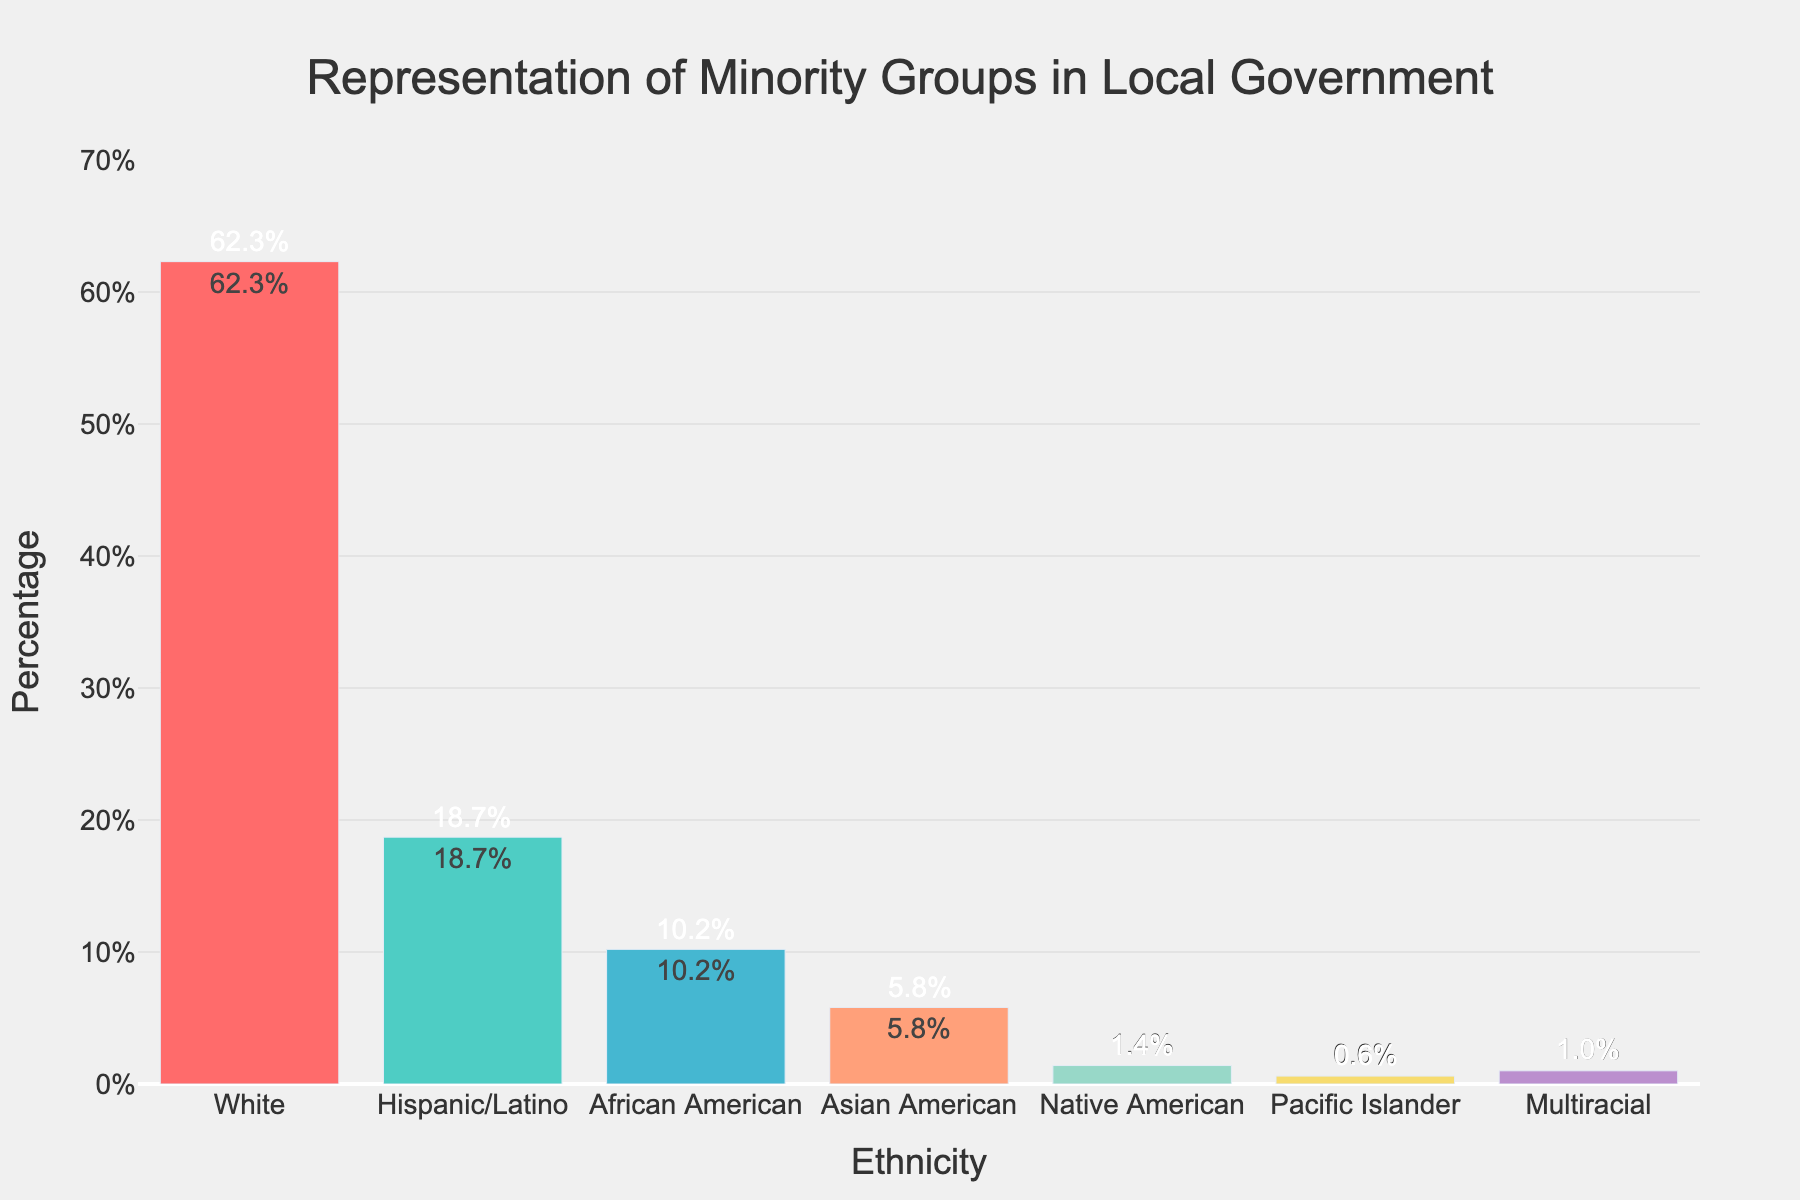What ethnicity has the highest percentage representation in local government according to the chart? By examining the heights of the bars, the bar for 'White' is the tallest, corresponding to the number 62.3. Therefore, 'White' has the highest percentage representation.
Answer: White Which ethnicities have a percentage representation of less than 2% in local government? By looking at the heights of the bars and their corresponding percentages, the 'Native American' (1.4%), 'Pacific Islander' (0.6%), and 'Multiracial' (1.0%) bars are all below 2%.
Answer: Native American, Pacific Islander, Multiracial How much higher is the representation of Hispanic/Latino compared to Asian American? The percentage for Hispanic/Latino is 18.7% and for Asian American is 5.8%. Subtracting these, 18.7 - 5.8 gives 12.9.
Answer: 12.9 What is the combined percentage representation of all groups besides 'White'? Adding the percentages of all other ethnic groups: 18.7 (Hispanic/Latino) + 10.2 (African American) + 5.8 (Asian American) + 1.4 (Native American) + 0.6 (Pacific Islander) + 1.0 (Multiracial) equals 37.7%.
Answer: 37.7% Which group has the smallest percentage representation in local government? By comparing the heights of the bars, the 'Pacific Islander' bar is the shortest, corresponding to 0.6%. Thus, Pacific Islander has the smallest representation.
Answer: Pacific Islander Is the representation of African American greater than that of Asian American and Native American combined? The percentage for African American is 10.2%. The combined percentage of Asian American (5.8%) and Native American (1.4%) is 5.8 + 1.4 = 7.2. Since 10.2 is greater than 7.2, the representation of African American is indeed greater.
Answer: Yes How many ethnicities have a percentage representation greater than 10%? By examining the chart, the 'White' (62.3%) and 'Hispanic/Latino' (18.7%) groups have representations greater than 10%. 'African American' (10.2%) is also greater than 10%. So, there are three ethnicities.
Answer: 3 What is the difference in percentage between the highest and the second highest group representations? The highest is 'White' at 62.3%, and the second highest is 'Hispanic/Latino' at 18.7%. Subtracting these, 62.3 - 18.7 gives 43.6.
Answer: 43.6 What is the average percentage representation of Hispanic/Latino, African American, Asian American, and Native American? Summing the percentages (18.7 + 10.2 + 5.8 + 1.4) gives a total of 36.1%. Dividing by 4 (the number of groups) gives 36.1 / 4 = 9.025.
Answer: 9.025 Which ethnicity is represented by the blue bar, and what is its percentage? By looking at the color pattern and checking the blue bar, it represents 'Asian American' which has the percentage label 5.8% on the bar.
Answer: Asian American, 5.8 